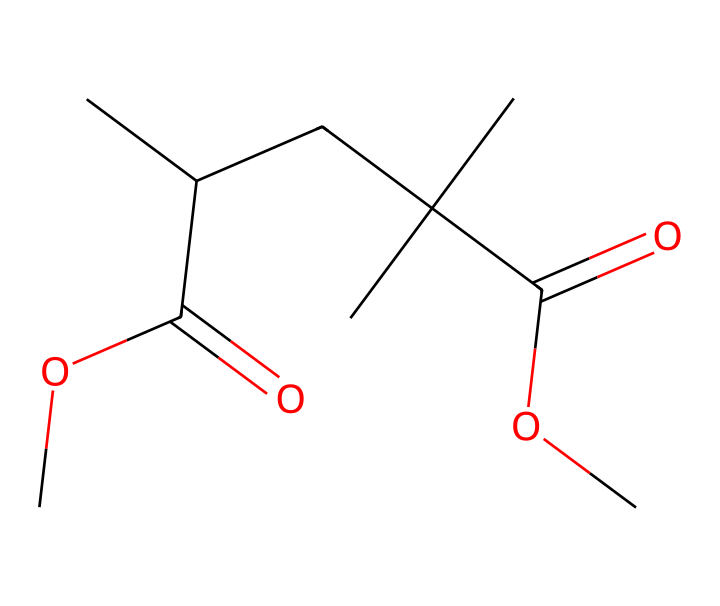What is the main functional group present in PMMA? The structure of PMMA includes an ester functional group indicated by the C=O and -O- parts of the molecule, which is characteristic of methacrylate esters.
Answer: ester How many carbon atoms are present in the PMMA structure? By examining the SMILES representation, there are 12 carbon atoms shown in the molecule, as each "C" in the representation corresponds to a carbon atom.
Answer: twelve What type of chemical is PMMA classified as? PMMA is classified as a synthetic polymer, specifically a thermoplastic, due to its large molecular structure derived from polymerization.
Answer: synthetic polymer How many ester groups are present in PMMA? The chemical structure contains two ester groups based on the C(=O)O features, which are identified in the SMILES notation indicating ester linkages.
Answer: two What characteristic property does PMMA exhibit as a positive photoresist? PMMA possesses a property of increased solubility in developer solutions after exposure to electron beams, which is a defining trait of positive photoresists, allowing for pattern transfer.
Answer: increased solubility What is the molecular formula derived from the structure of PMMA? Analyzing the composition from the given SMILES representation, the molecular formula can be deduced as C12H22O4 by counting each atom represented.
Answer: C12H22O4 